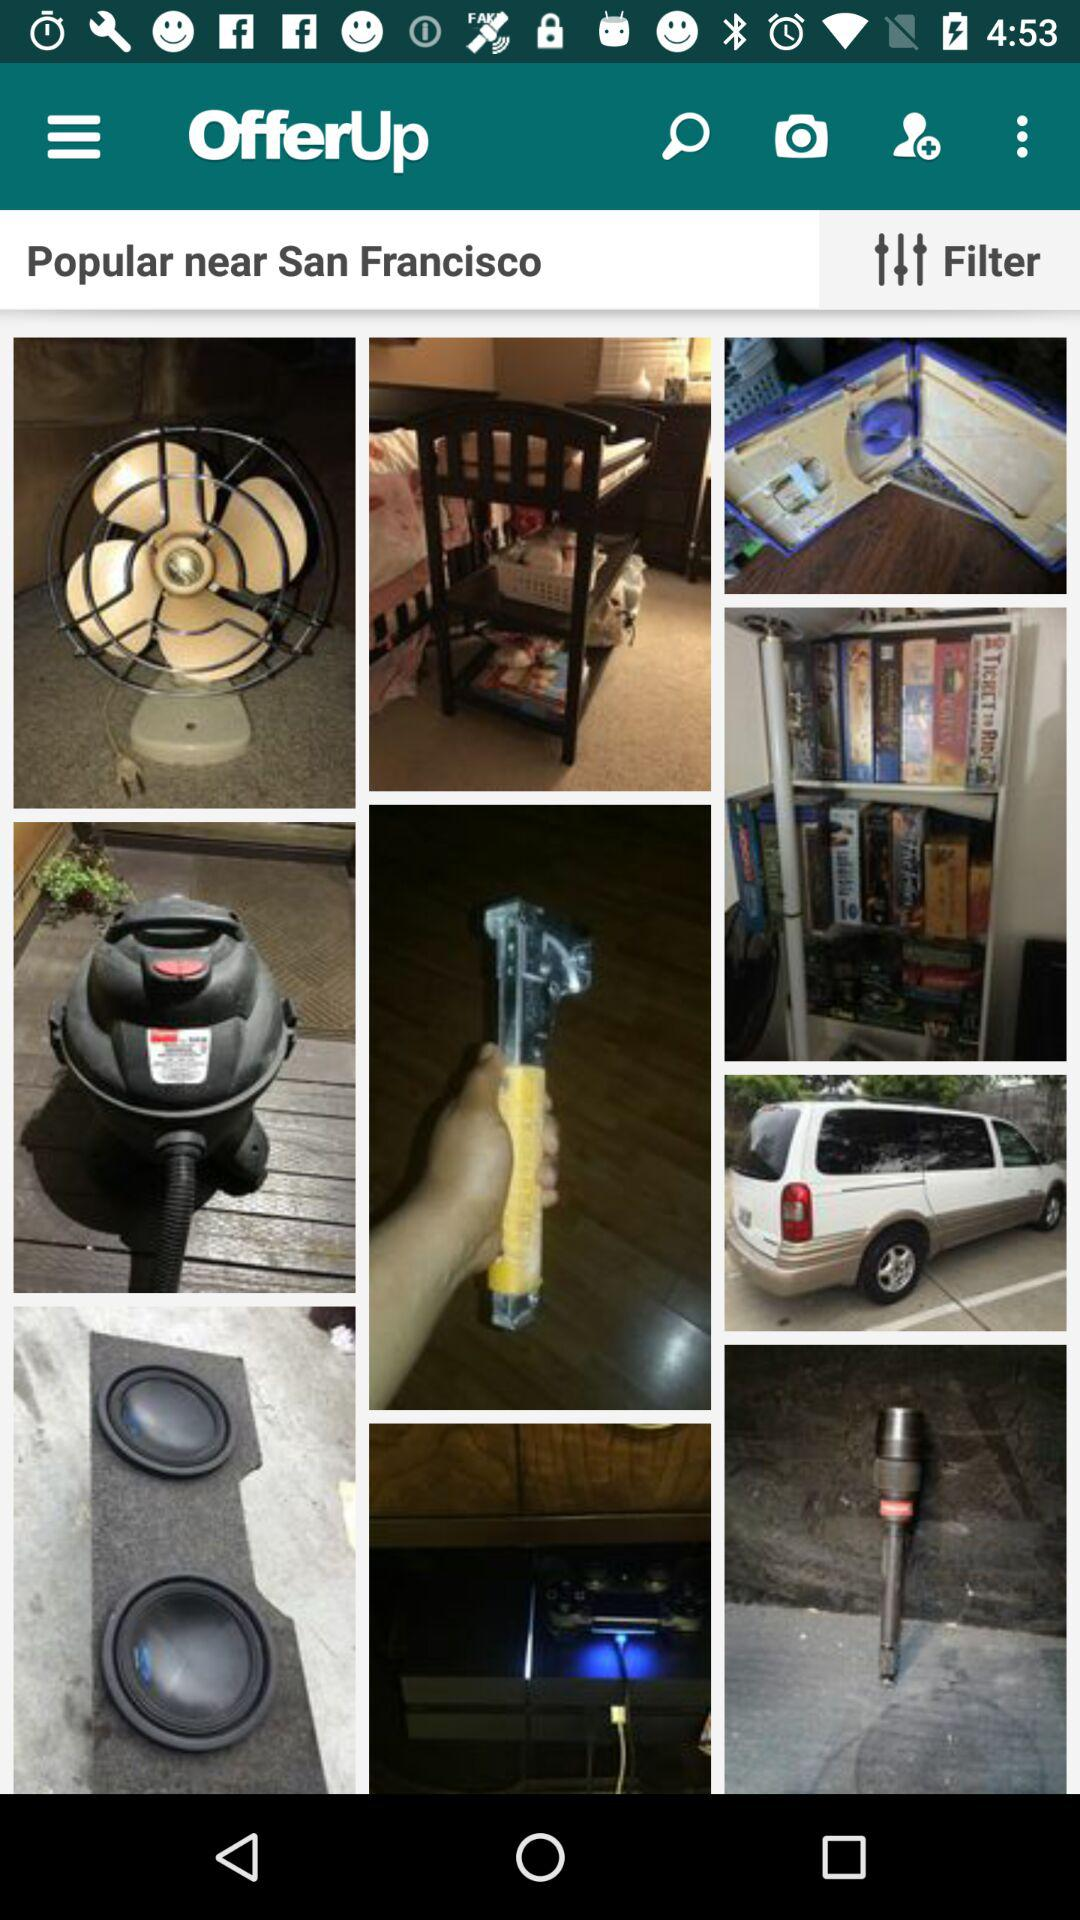What is the name of the application? The application name is "OfferUp". 